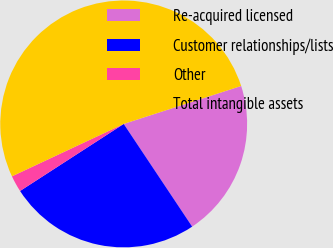Convert chart. <chart><loc_0><loc_0><loc_500><loc_500><pie_chart><fcel>Re-acquired licensed<fcel>Customer relationships/lists<fcel>Other<fcel>Total intangible assets<nl><fcel>20.62%<fcel>25.22%<fcel>2.16%<fcel>52.01%<nl></chart> 